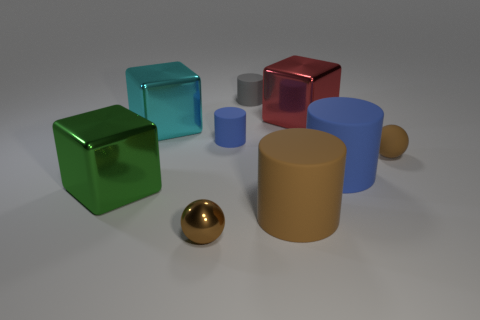Subtract all brown matte cylinders. How many cylinders are left? 3 Subtract all brown cylinders. How many cylinders are left? 3 Subtract 0 brown blocks. How many objects are left? 9 Subtract all balls. How many objects are left? 7 Subtract 1 cylinders. How many cylinders are left? 3 Subtract all red balls. Subtract all gray cylinders. How many balls are left? 2 Subtract all green blocks. How many yellow cylinders are left? 0 Subtract all small matte objects. Subtract all small brown shiny objects. How many objects are left? 5 Add 8 large brown matte objects. How many large brown matte objects are left? 9 Add 7 large cubes. How many large cubes exist? 10 